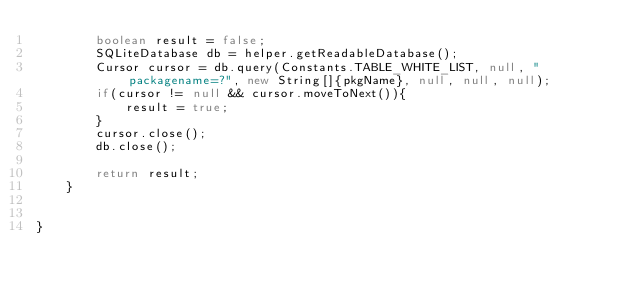Convert code to text. <code><loc_0><loc_0><loc_500><loc_500><_Java_>        boolean result = false;
        SQLiteDatabase db = helper.getReadableDatabase();
        Cursor cursor = db.query(Constants.TABLE_WHITE_LIST, null, "packagename=?", new String[]{pkgName}, null, null, null);
        if(cursor != null && cursor.moveToNext()){
            result = true;
        }
        cursor.close();
        db.close();

        return result;
    }


}
</code> 